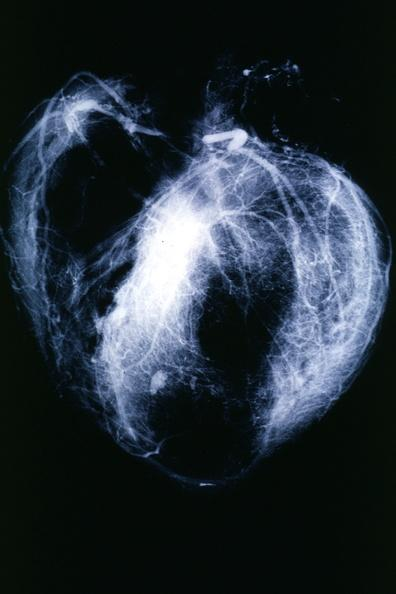s cardiovascular present?
Answer the question using a single word or phrase. Yes 